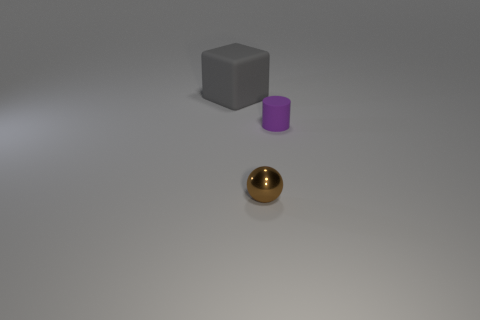There is a brown metallic object; is its shape the same as the matte object to the left of the purple matte thing?
Provide a short and direct response. No. Is the number of large brown cylinders greater than the number of blocks?
Your answer should be very brief. No. What shape is the purple thing that is made of the same material as the big block?
Provide a succinct answer. Cylinder. There is a thing that is in front of the rubber object right of the big gray rubber cube; what is its material?
Your response must be concise. Metal. There is a rubber object that is in front of the gray rubber thing; is its shape the same as the big gray matte thing?
Offer a very short reply. No. Are there more spheres that are in front of the large matte cube than small cyan metallic blocks?
Your answer should be compact. Yes. Are there any other things that are the same material as the brown object?
Your answer should be very brief. No. What number of cubes are either large gray objects or big green metal objects?
Provide a succinct answer. 1. There is a object in front of the rubber thing right of the gray thing; what color is it?
Provide a succinct answer. Brown. The purple object that is made of the same material as the big gray object is what size?
Give a very brief answer. Small. 